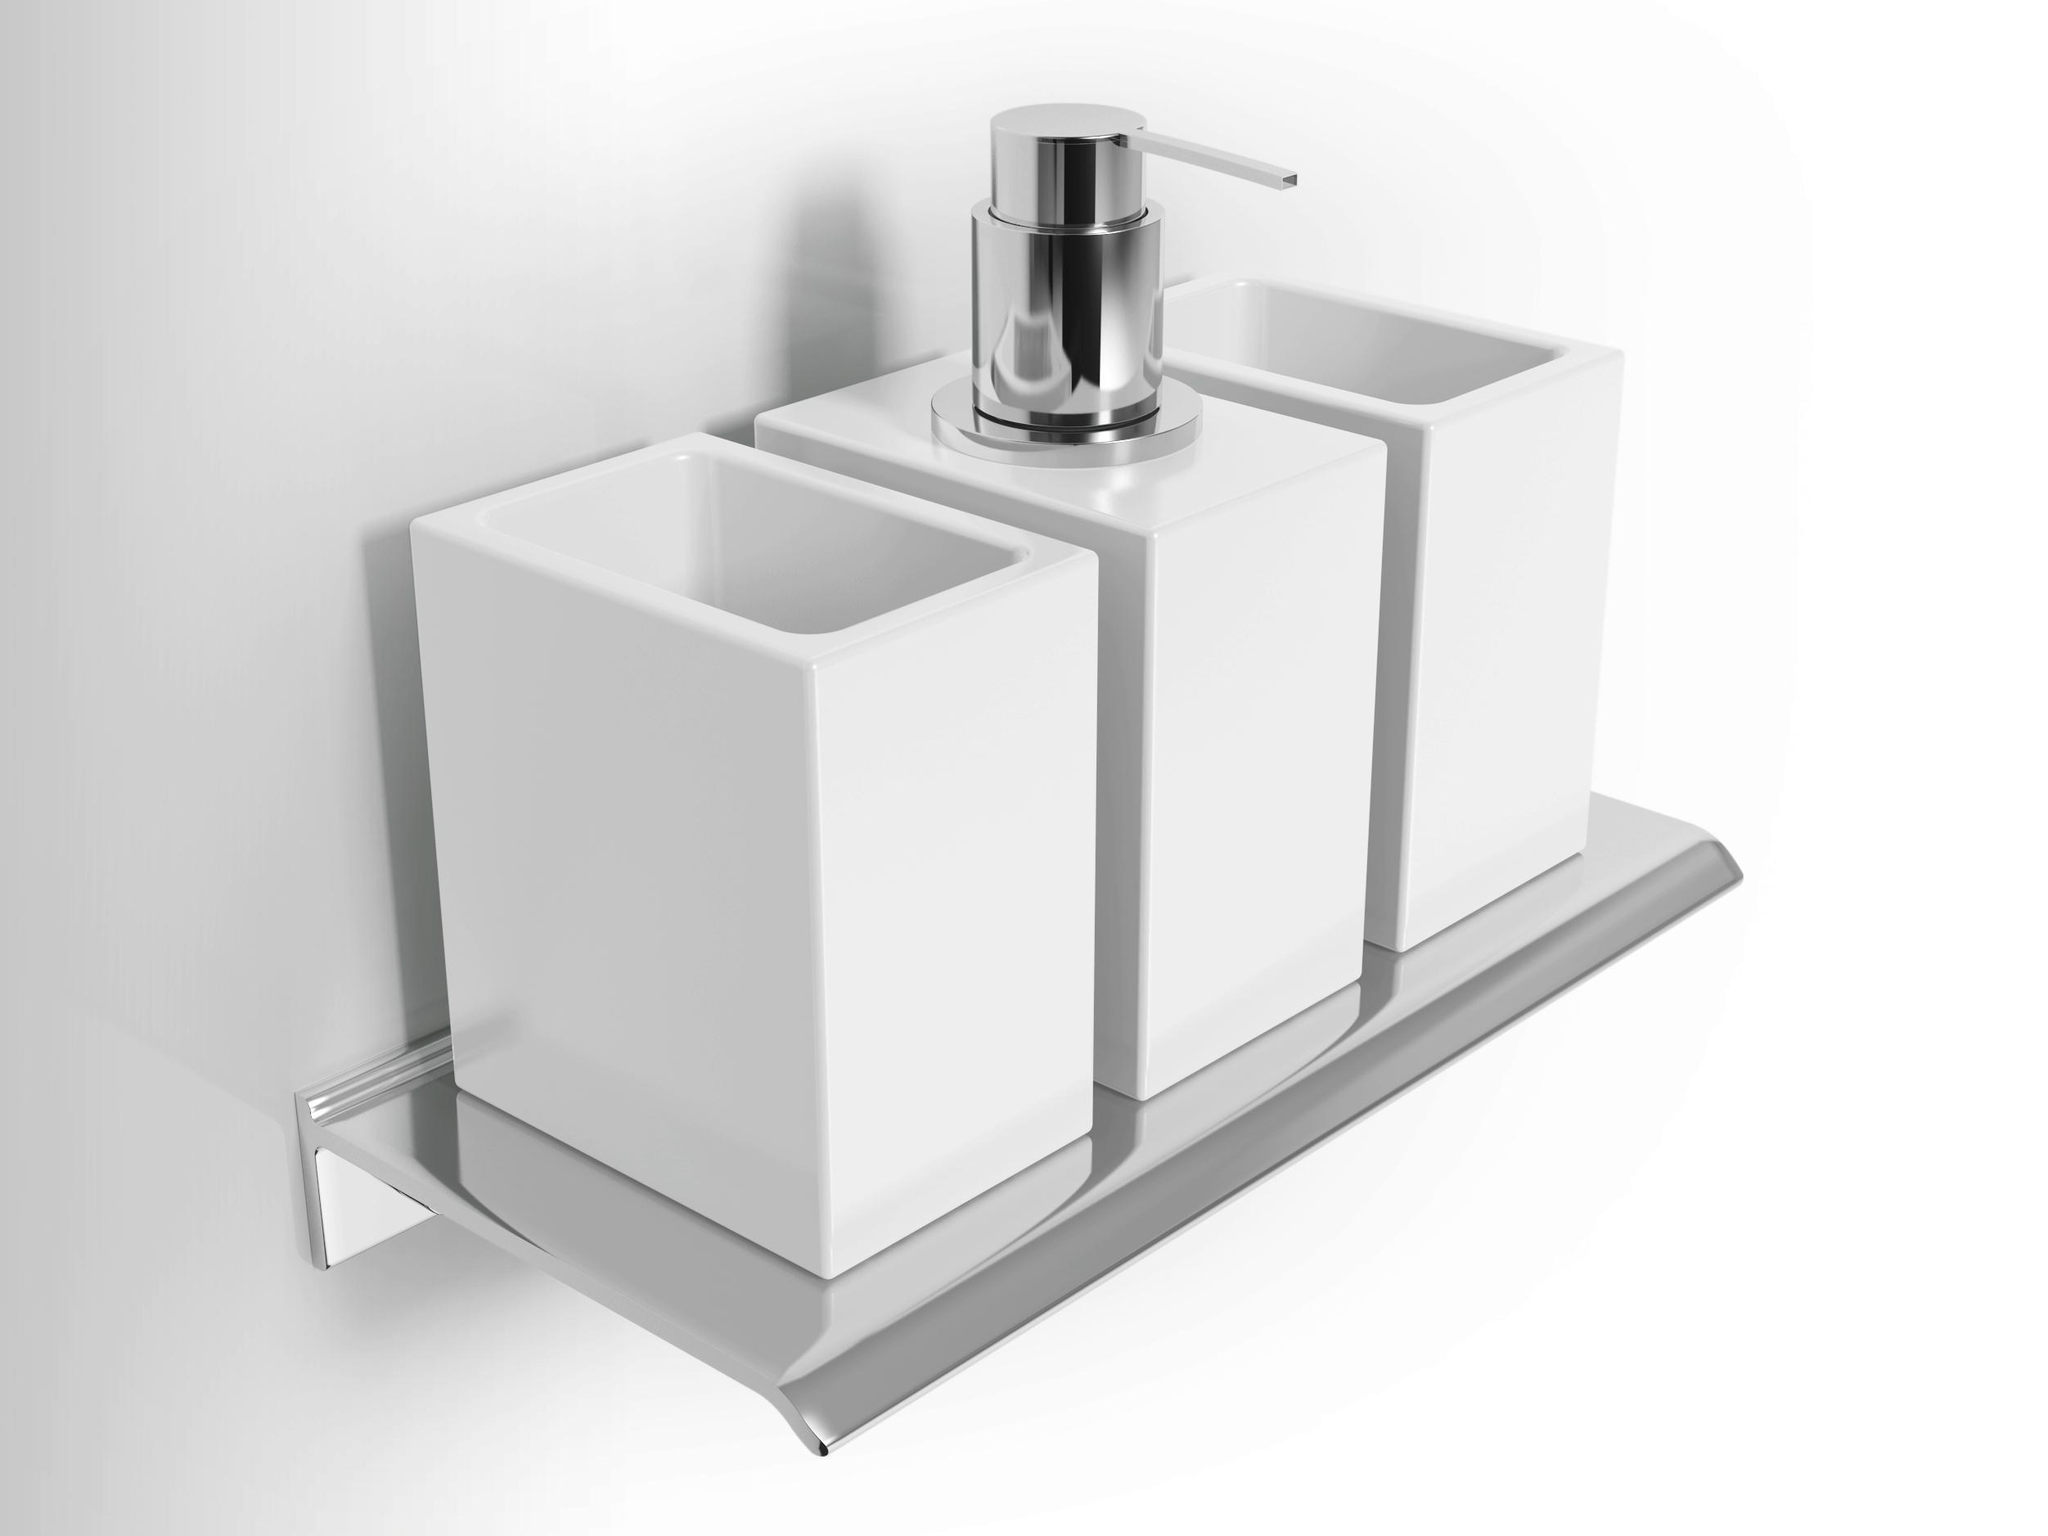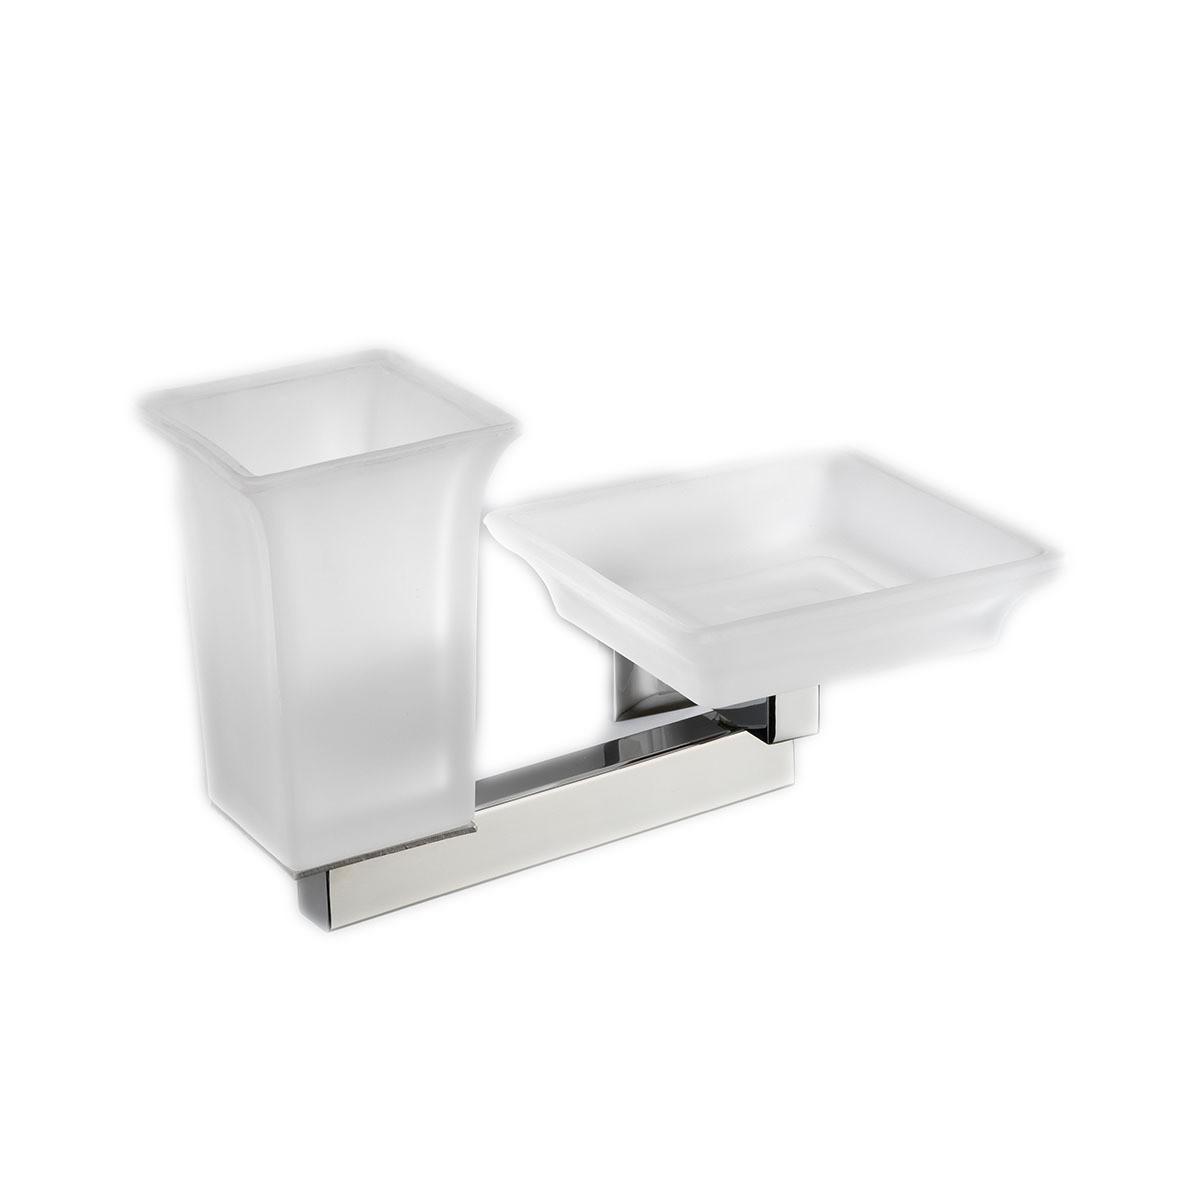The first image is the image on the left, the second image is the image on the right. For the images shown, is this caption "The image on the right contains a grouping of four containers with a pump in the center of the back row of three." true? Answer yes or no. No. 